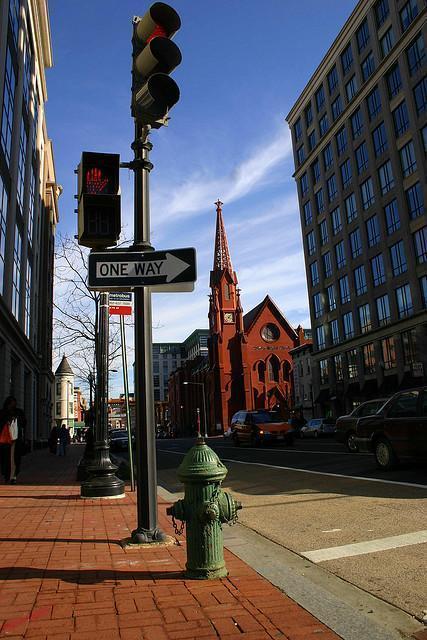Which way can those cars turn?
Answer the question by selecting the correct answer among the 4 following choices and explain your choice with a short sentence. The answer should be formatted with the following format: `Answer: choice
Rationale: rationale.`
Options: Their right, no turn, unclear, their left. Answer: their left.
Rationale: The sign is facing right which is the car driver's left. 